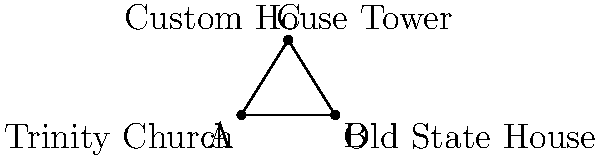As a law enthusiast exploring downtown Boston, you notice an interesting geometric relationship between three landmark buildings: Trinity Church (A), Old State House (B), and Custom House Tower (C). The distance between Trinity Church and Old State House is 2.5 km, and the distance between Trinity Church and Custom House Tower is 4 km. If the angle formed by these three buildings at Trinity Church is a right angle, what is the distance between Old State House and Custom House Tower? Let's approach this step-by-step using the Pythagorean theorem:

1) We can treat this scenario as a right-angled triangle, where:
   - Trinity Church (A) forms the right angle
   - AB = 2.5 km (distance between Trinity Church and Old State House)
   - AC = 4 km (distance between Trinity Church and Custom House Tower)
   - BC is the distance we need to find

2) According to the Pythagorean theorem:
   $$ BC^2 = AB^2 + AC^2 $$

3) Substituting the known values:
   $$ BC^2 = 2.5^2 + 4^2 $$

4) Simplifying:
   $$ BC^2 = 6.25 + 16 = 22.25 $$

5) Taking the square root of both sides:
   $$ BC = \sqrt{22.25} $$

6) Simplifying the square root:
   $$ BC = \sqrt{22.25} = 4.72 \text{ km (rounded to two decimal places)} $$

Therefore, the distance between Old State House and Custom House Tower is approximately 4.72 km.
Answer: 4.72 km 